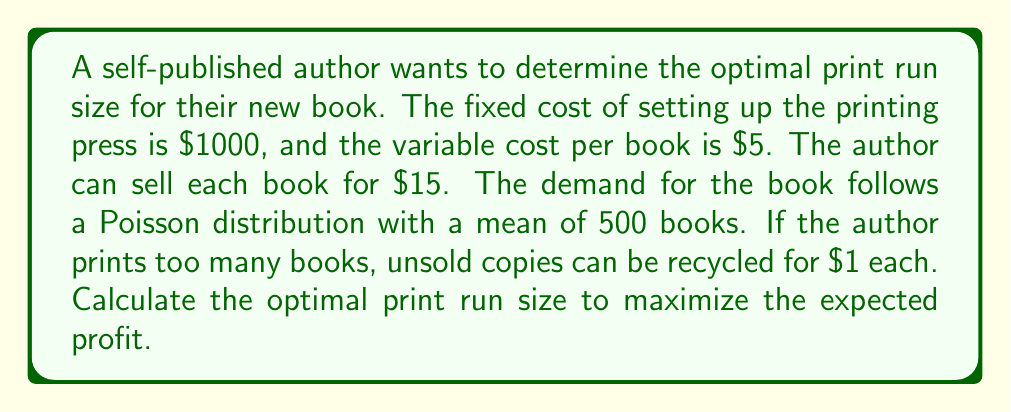Teach me how to tackle this problem. Let's approach this problem step-by-step using stochastic processes:

1) Let $X$ be the random variable representing the demand, which follows a Poisson distribution with mean $\lambda = 500$.

2) Let $n$ be the print run size.

3) The expected profit function $E[P(n)]$ is:

   $$E[P(n)] = 15E[\min(X,n)] + 1E[\max(0,n-X)] - 5n - 1000$$

4) We can simplify this using the properties of the Poisson distribution:

   $$E[P(n)] = 15\sum_{x=0}^{n-1} x\frac{e^{-\lambda}\lambda^x}{x!} + 15n\sum_{x=n}^{\infty} \frac{e^{-\lambda}\lambda^x}{x!} + n - E[X] - 5n - 1000$$

5) To find the optimal $n$, we need to find where the derivative of $E[P(n)]$ with respect to $n$ equals zero:

   $$\frac{d}{dn}E[P(n)] = 15\sum_{x=n}^{\infty} \frac{e^{-\lambda}\lambda^x}{x!} + 1 - 5 = 0$$

6) Simplifying:

   $$\sum_{x=n}^{\infty} \frac{e^{-\lambda}\lambda^x}{x!} = \frac{4}{15}$$

7) This equation can be solved numerically. Using a computer or calculator, we find that the solution is approximately $n \approx 544$.

8) To verify this is a maximum, we can check that the second derivative is negative at this point.
Answer: 544 books 